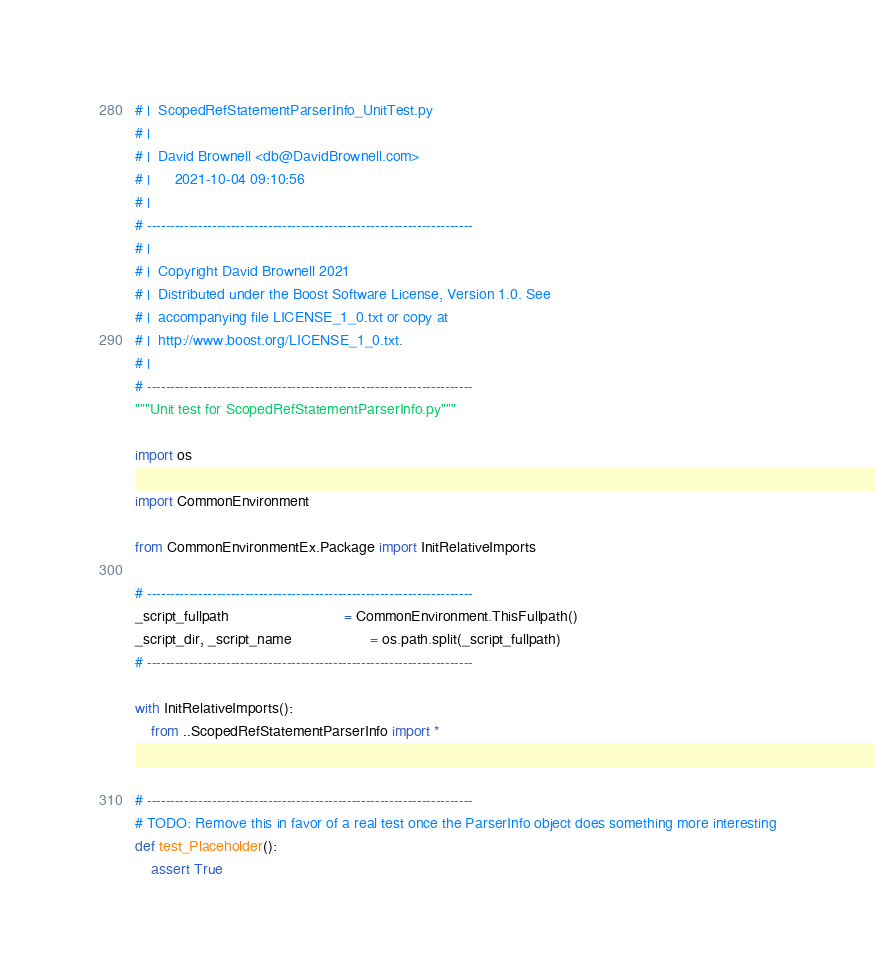Convert code to text. <code><loc_0><loc_0><loc_500><loc_500><_Python_># |  ScopedRefStatementParserInfo_UnitTest.py
# |
# |  David Brownell <db@DavidBrownell.com>
# |      2021-10-04 09:10:56
# |
# ----------------------------------------------------------------------
# |
# |  Copyright David Brownell 2021
# |  Distributed under the Boost Software License, Version 1.0. See
# |  accompanying file LICENSE_1_0.txt or copy at
# |  http://www.boost.org/LICENSE_1_0.txt.
# |
# ----------------------------------------------------------------------
"""Unit test for ScopedRefStatementParserInfo.py"""

import os

import CommonEnvironment

from CommonEnvironmentEx.Package import InitRelativeImports

# ----------------------------------------------------------------------
_script_fullpath                            = CommonEnvironment.ThisFullpath()
_script_dir, _script_name                   = os.path.split(_script_fullpath)
# ----------------------------------------------------------------------

with InitRelativeImports():
    from ..ScopedRefStatementParserInfo import *


# ----------------------------------------------------------------------
# TODO: Remove this in favor of a real test once the ParserInfo object does something more interesting
def test_Placeholder():
    assert True
</code> 